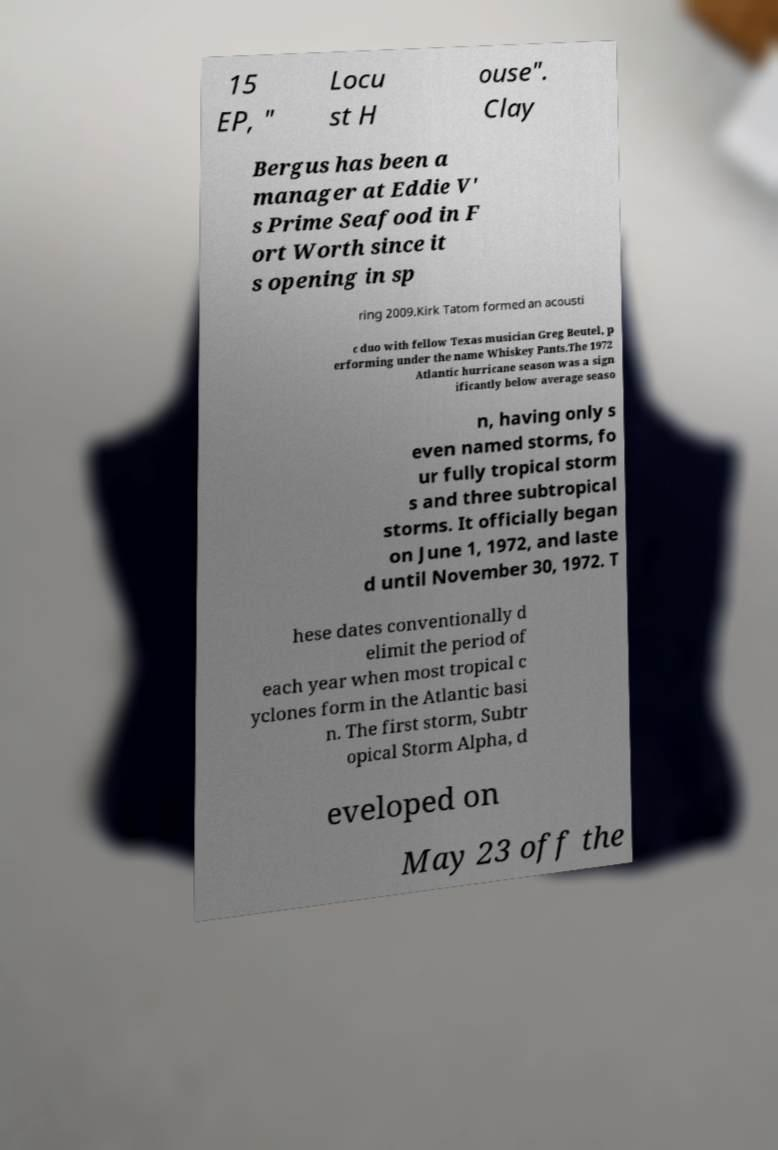For documentation purposes, I need the text within this image transcribed. Could you provide that? 15 EP, " Locu st H ouse". Clay Bergus has been a manager at Eddie V' s Prime Seafood in F ort Worth since it s opening in sp ring 2009.Kirk Tatom formed an acousti c duo with fellow Texas musician Greg Beutel, p erforming under the name Whiskey Pants.The 1972 Atlantic hurricane season was a sign ificantly below average seaso n, having only s even named storms, fo ur fully tropical storm s and three subtropical storms. It officially began on June 1, 1972, and laste d until November 30, 1972. T hese dates conventionally d elimit the period of each year when most tropical c yclones form in the Atlantic basi n. The first storm, Subtr opical Storm Alpha, d eveloped on May 23 off the 